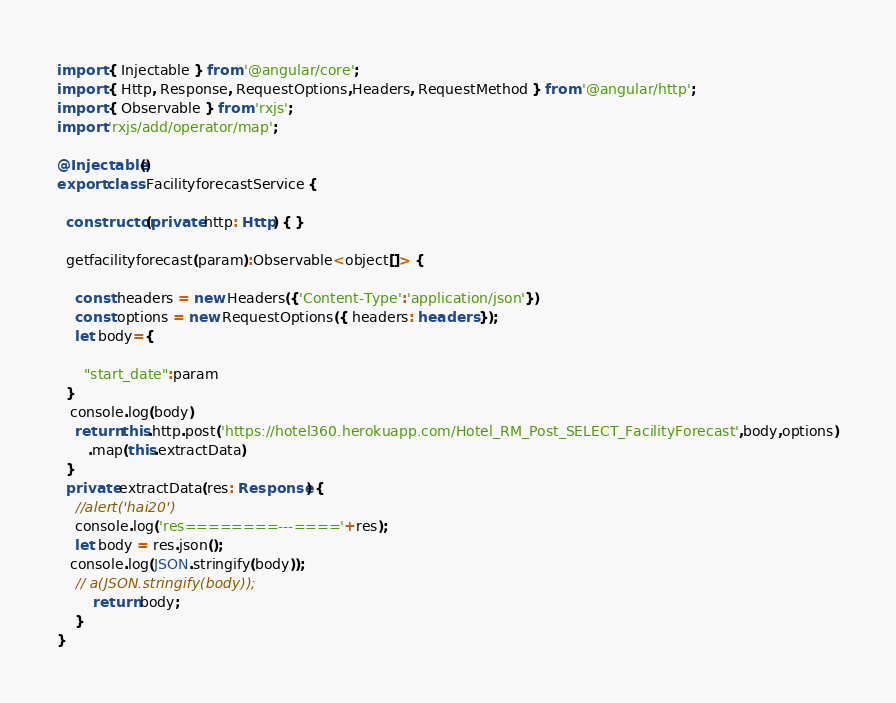<code> <loc_0><loc_0><loc_500><loc_500><_TypeScript_>import { Injectable } from '@angular/core';
import { Http, Response, RequestOptions,Headers, RequestMethod } from '@angular/http';
import { Observable } from 'rxjs';
import 'rxjs/add/operator/map';

@Injectable()
export class FacilityforecastService {

  constructor(private http: Http) { }

  getfacilityforecast(param):Observable<object[]> {
       
    const headers = new Headers({'Content-Type':'application/json'})
    const options = new RequestOptions({ headers: headers });
    let body={
    
      "start_date":param
  }
   console.log(body)
    return this.http.post('https://hotel360.herokuapp.com/Hotel_RM_Post_SELECT_FacilityForecast',body,options)
       .map(this.extractData)
  }
  private extractData(res: Response) {
    //alert('hai20')
    console.log('res========---===='+res);
    let body = res.json();
   console.log(JSON.stringify(body));
    // a(JSON.stringify(body));
        return body;
    }
}
</code> 